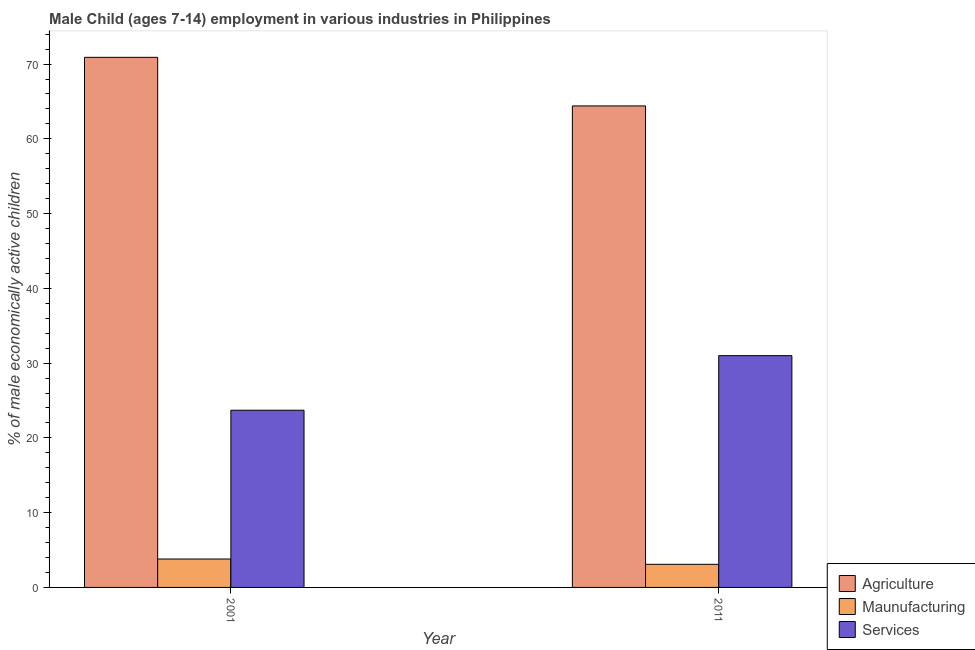How many groups of bars are there?
Your response must be concise. 2. Are the number of bars on each tick of the X-axis equal?
Offer a very short reply. Yes. How many bars are there on the 1st tick from the left?
Offer a terse response. 3. How many bars are there on the 1st tick from the right?
Make the answer very short. 3. What is the label of the 2nd group of bars from the left?
Ensure brevity in your answer.  2011. What is the percentage of economically active children in manufacturing in 2011?
Your answer should be very brief. 3.09. Across all years, what is the minimum percentage of economically active children in services?
Provide a short and direct response. 23.7. In which year was the percentage of economically active children in services maximum?
Ensure brevity in your answer.  2011. In which year was the percentage of economically active children in agriculture minimum?
Your answer should be very brief. 2011. What is the total percentage of economically active children in services in the graph?
Your answer should be very brief. 54.7. What is the difference between the percentage of economically active children in manufacturing in 2001 and that in 2011?
Your answer should be compact. 0.71. What is the difference between the percentage of economically active children in agriculture in 2011 and the percentage of economically active children in services in 2001?
Your answer should be very brief. -6.5. What is the average percentage of economically active children in services per year?
Make the answer very short. 27.35. In the year 2001, what is the difference between the percentage of economically active children in manufacturing and percentage of economically active children in agriculture?
Your response must be concise. 0. In how many years, is the percentage of economically active children in services greater than 28 %?
Offer a very short reply. 1. What is the ratio of the percentage of economically active children in agriculture in 2001 to that in 2011?
Provide a succinct answer. 1.1. Is the percentage of economically active children in manufacturing in 2001 less than that in 2011?
Offer a very short reply. No. In how many years, is the percentage of economically active children in agriculture greater than the average percentage of economically active children in agriculture taken over all years?
Keep it short and to the point. 1. What does the 1st bar from the left in 2001 represents?
Give a very brief answer. Agriculture. What does the 2nd bar from the right in 2001 represents?
Your answer should be very brief. Maunufacturing. How many bars are there?
Offer a very short reply. 6. Are all the bars in the graph horizontal?
Make the answer very short. No. Does the graph contain grids?
Offer a very short reply. No. How many legend labels are there?
Give a very brief answer. 3. What is the title of the graph?
Your answer should be very brief. Male Child (ages 7-14) employment in various industries in Philippines. What is the label or title of the Y-axis?
Your response must be concise. % of male economically active children. What is the % of male economically active children in Agriculture in 2001?
Provide a short and direct response. 70.9. What is the % of male economically active children of Services in 2001?
Keep it short and to the point. 23.7. What is the % of male economically active children in Agriculture in 2011?
Provide a succinct answer. 64.4. What is the % of male economically active children of Maunufacturing in 2011?
Your answer should be compact. 3.09. Across all years, what is the maximum % of male economically active children of Agriculture?
Your answer should be very brief. 70.9. Across all years, what is the maximum % of male economically active children in Maunufacturing?
Your answer should be very brief. 3.8. Across all years, what is the minimum % of male economically active children of Agriculture?
Offer a terse response. 64.4. Across all years, what is the minimum % of male economically active children in Maunufacturing?
Make the answer very short. 3.09. Across all years, what is the minimum % of male economically active children in Services?
Your answer should be very brief. 23.7. What is the total % of male economically active children in Agriculture in the graph?
Provide a short and direct response. 135.3. What is the total % of male economically active children in Maunufacturing in the graph?
Provide a succinct answer. 6.89. What is the total % of male economically active children of Services in the graph?
Provide a short and direct response. 54.7. What is the difference between the % of male economically active children of Maunufacturing in 2001 and that in 2011?
Your response must be concise. 0.71. What is the difference between the % of male economically active children in Agriculture in 2001 and the % of male economically active children in Maunufacturing in 2011?
Keep it short and to the point. 67.81. What is the difference between the % of male economically active children in Agriculture in 2001 and the % of male economically active children in Services in 2011?
Ensure brevity in your answer.  39.9. What is the difference between the % of male economically active children in Maunufacturing in 2001 and the % of male economically active children in Services in 2011?
Provide a short and direct response. -27.2. What is the average % of male economically active children of Agriculture per year?
Provide a short and direct response. 67.65. What is the average % of male economically active children in Maunufacturing per year?
Your answer should be very brief. 3.44. What is the average % of male economically active children of Services per year?
Provide a succinct answer. 27.35. In the year 2001, what is the difference between the % of male economically active children in Agriculture and % of male economically active children in Maunufacturing?
Your response must be concise. 67.1. In the year 2001, what is the difference between the % of male economically active children in Agriculture and % of male economically active children in Services?
Give a very brief answer. 47.2. In the year 2001, what is the difference between the % of male economically active children in Maunufacturing and % of male economically active children in Services?
Give a very brief answer. -19.9. In the year 2011, what is the difference between the % of male economically active children in Agriculture and % of male economically active children in Maunufacturing?
Make the answer very short. 61.31. In the year 2011, what is the difference between the % of male economically active children of Agriculture and % of male economically active children of Services?
Provide a succinct answer. 33.4. In the year 2011, what is the difference between the % of male economically active children in Maunufacturing and % of male economically active children in Services?
Your response must be concise. -27.91. What is the ratio of the % of male economically active children in Agriculture in 2001 to that in 2011?
Your response must be concise. 1.1. What is the ratio of the % of male economically active children in Maunufacturing in 2001 to that in 2011?
Offer a terse response. 1.23. What is the ratio of the % of male economically active children in Services in 2001 to that in 2011?
Offer a terse response. 0.76. What is the difference between the highest and the second highest % of male economically active children of Maunufacturing?
Provide a short and direct response. 0.71. What is the difference between the highest and the second highest % of male economically active children of Services?
Ensure brevity in your answer.  7.3. What is the difference between the highest and the lowest % of male economically active children of Agriculture?
Offer a very short reply. 6.5. What is the difference between the highest and the lowest % of male economically active children in Maunufacturing?
Offer a terse response. 0.71. What is the difference between the highest and the lowest % of male economically active children of Services?
Keep it short and to the point. 7.3. 